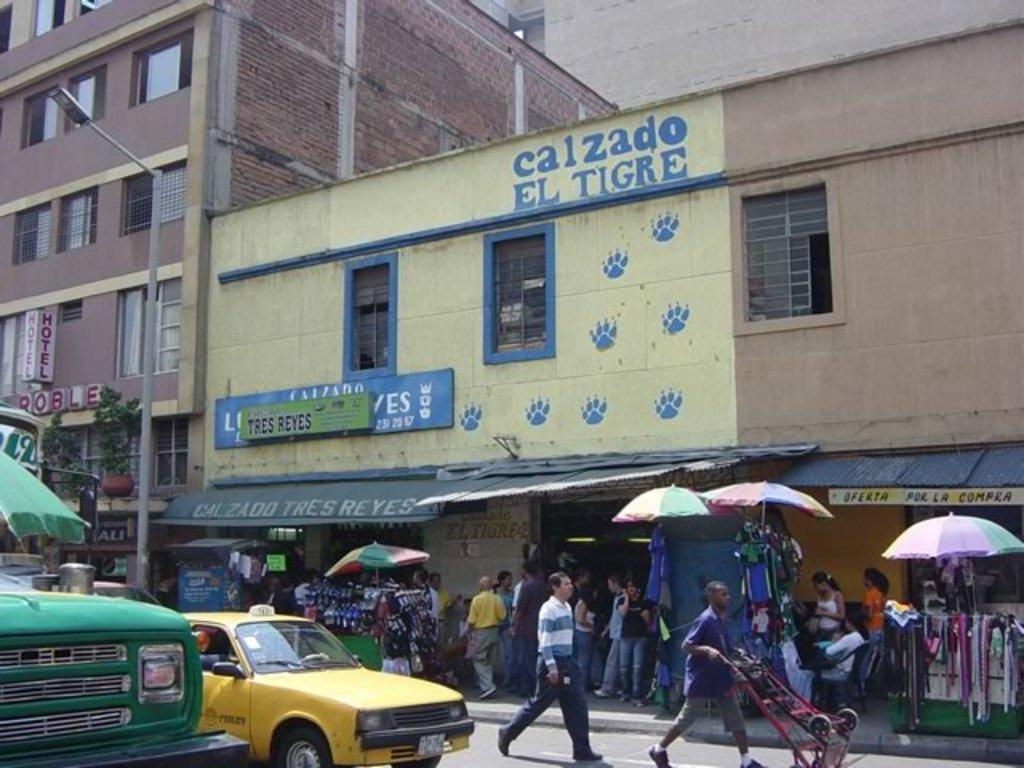<image>
Give a short and clear explanation of the subsequent image. The yellow store has the words Calzado on it 